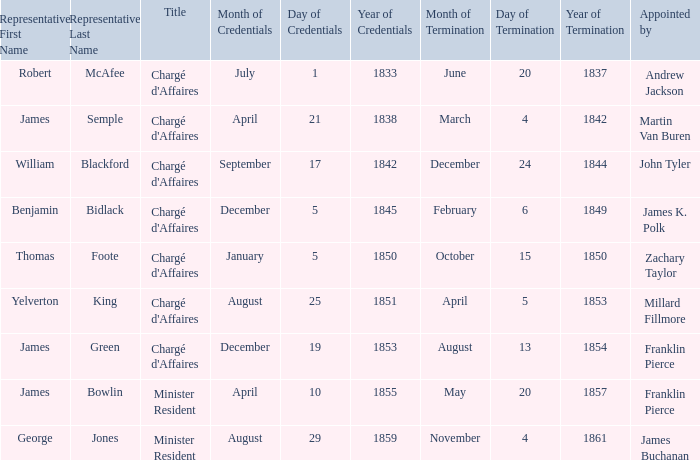What's the Representative listed that has a Presentation of Credentials of August 25, 1851? Yelverton P. King. 